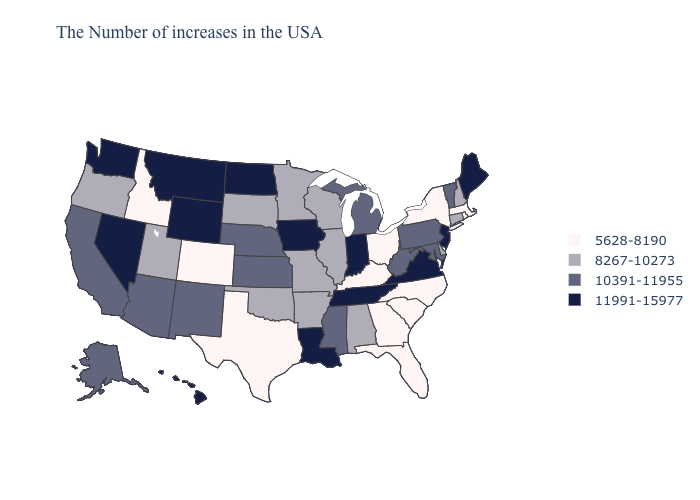Does Florida have the lowest value in the USA?
Give a very brief answer. Yes. Does the first symbol in the legend represent the smallest category?
Answer briefly. Yes. Name the states that have a value in the range 11991-15977?
Give a very brief answer. Maine, New Jersey, Virginia, Indiana, Tennessee, Louisiana, Iowa, North Dakota, Wyoming, Montana, Nevada, Washington, Hawaii. Which states hav the highest value in the South?
Quick response, please. Virginia, Tennessee, Louisiana. Name the states that have a value in the range 11991-15977?
Be succinct. Maine, New Jersey, Virginia, Indiana, Tennessee, Louisiana, Iowa, North Dakota, Wyoming, Montana, Nevada, Washington, Hawaii. Name the states that have a value in the range 5628-8190?
Keep it brief. Massachusetts, Rhode Island, New York, North Carolina, South Carolina, Ohio, Florida, Georgia, Kentucky, Texas, Colorado, Idaho. What is the value of New Mexico?
Answer briefly. 10391-11955. Among the states that border Vermont , does New Hampshire have the lowest value?
Quick response, please. No. Among the states that border Virginia , does Maryland have the lowest value?
Write a very short answer. No. What is the value of Utah?
Keep it brief. 8267-10273. What is the highest value in the Northeast ?
Give a very brief answer. 11991-15977. Name the states that have a value in the range 5628-8190?
Write a very short answer. Massachusetts, Rhode Island, New York, North Carolina, South Carolina, Ohio, Florida, Georgia, Kentucky, Texas, Colorado, Idaho. Which states hav the highest value in the Northeast?
Concise answer only. Maine, New Jersey. Does the map have missing data?
Be succinct. No. What is the lowest value in the South?
Keep it brief. 5628-8190. 